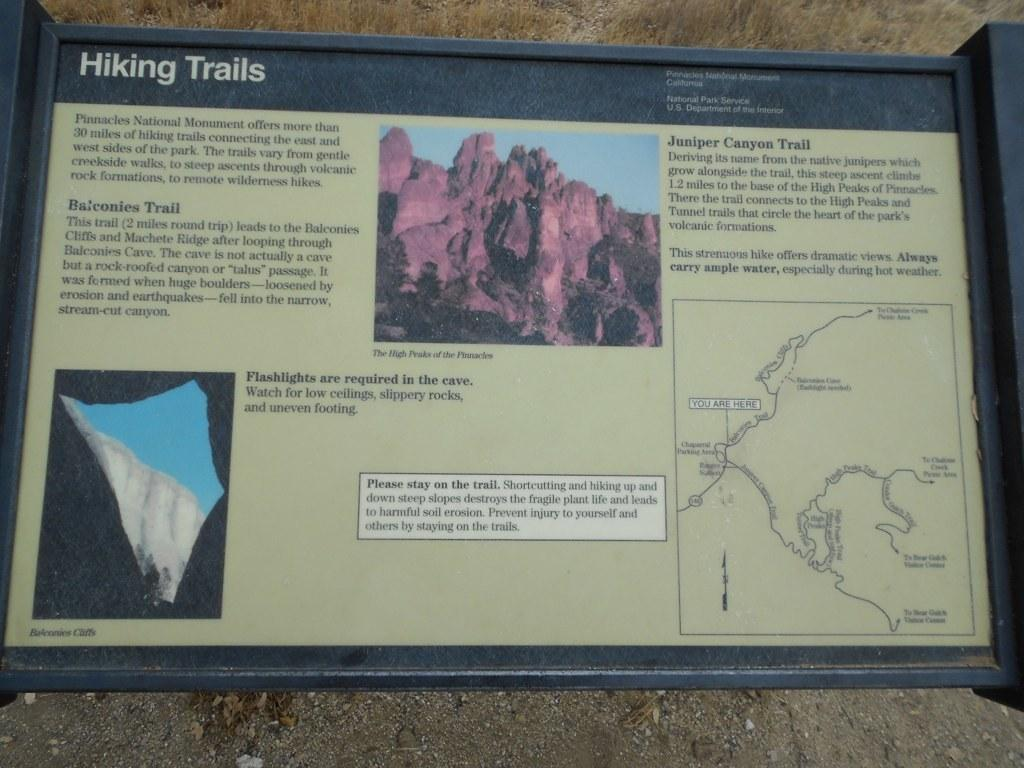<image>
Describe the image concisely. An outdoor informational display for hiking trails at Juniper Canyon. 